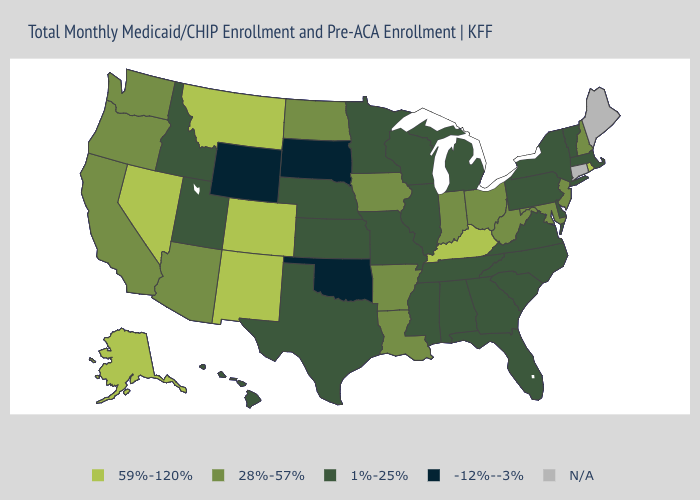What is the highest value in the USA?
Answer briefly. 59%-120%. Name the states that have a value in the range 28%-57%?
Write a very short answer. Arizona, Arkansas, California, Indiana, Iowa, Louisiana, Maryland, New Hampshire, New Jersey, North Dakota, Ohio, Oregon, Washington, West Virginia. What is the highest value in states that border Delaware?
Give a very brief answer. 28%-57%. What is the highest value in the West ?
Be succinct. 59%-120%. What is the highest value in the MidWest ?
Quick response, please. 28%-57%. Among the states that border Georgia , which have the lowest value?
Quick response, please. Alabama, Florida, North Carolina, South Carolina, Tennessee. Which states have the lowest value in the West?
Write a very short answer. Wyoming. Does Colorado have the highest value in the USA?
Be succinct. Yes. Does Kentucky have the lowest value in the South?
Give a very brief answer. No. What is the value of Washington?
Short answer required. 28%-57%. What is the lowest value in the MidWest?
Keep it brief. -12%--3%. Is the legend a continuous bar?
Keep it brief. No. What is the value of Georgia?
Concise answer only. 1%-25%. 